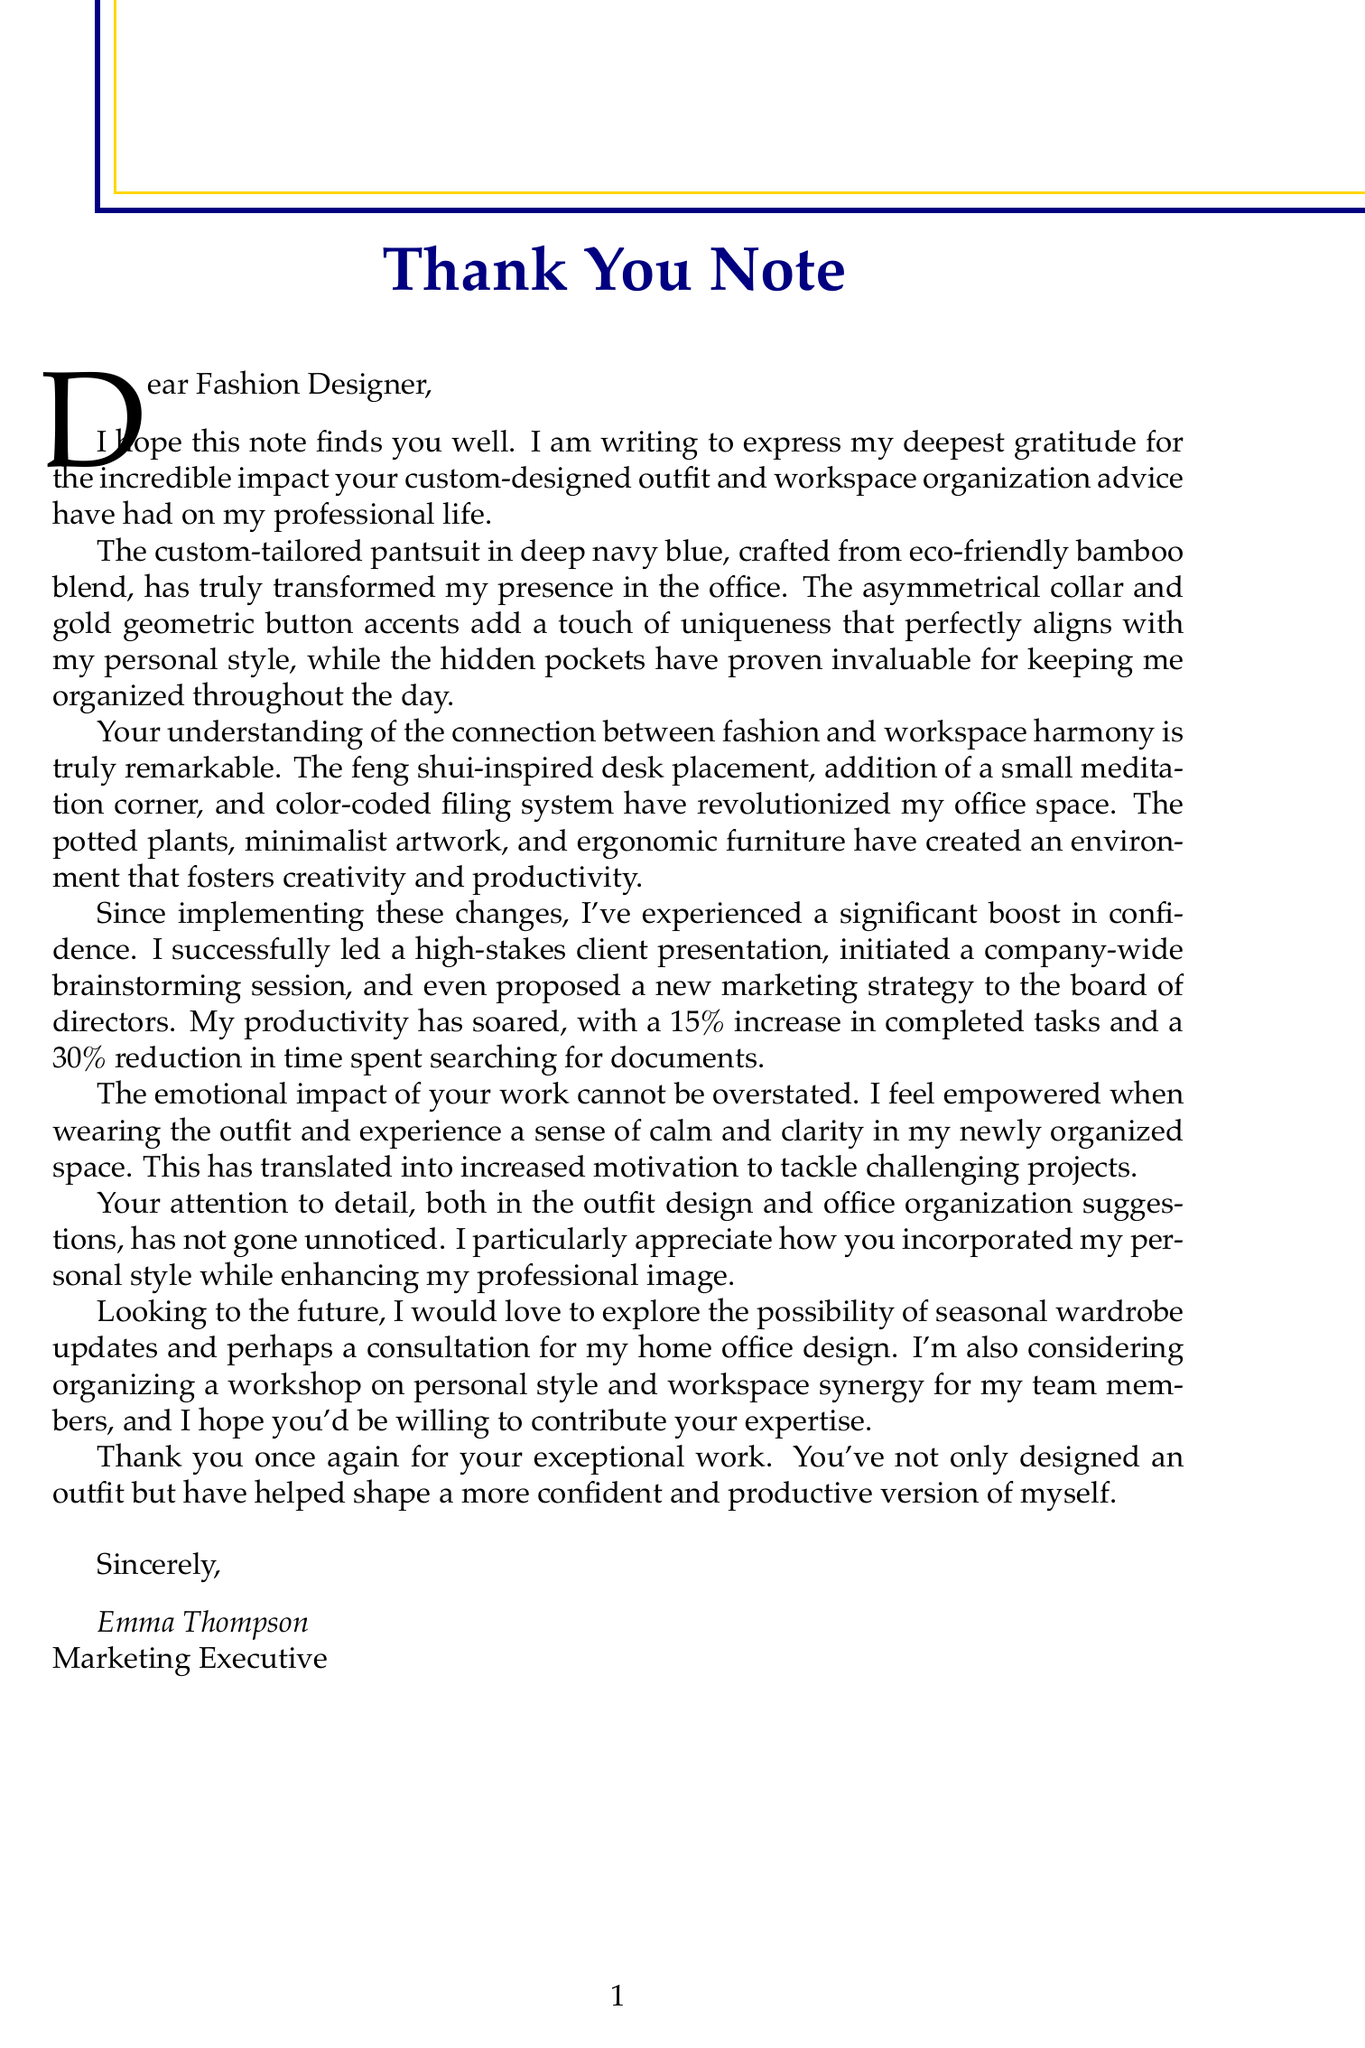What is the client's name? The client's name is mentioned at the beginning of the letter as Emma Thompson.
Answer: Emma Thompson What color is the custom-tailored pantsuit? The outfit description states the color of the pantsuit is deep navy blue.
Answer: Deep navy blue What percentage increase in completed tasks did the client experience? The productivity improvements section specifies a 15% increase in completed tasks.
Answer: 15% What type of furniture is mentioned in the office decor? The document refers to ergonomic furniture as part of the decor elements.
Answer: Ergonomic furniture Which feature of the outfit helps the client stay organized? The letter highlights hidden pockets as a feature that helps with organization.
Answer: Hidden pockets What emotional feeling does the client associate with wearing the outfit? The emotional impact section indicates the client feels empowered when wearing the outfit.
Answer: Empowered How much time did the client reduce searching for documents? The document notes a 30% reduction in time spent searching for documents.
Answer: 30% What future collaboration idea involves workshops? The client expresses interest in organizing a workshop on personal style and workspace synergy for team members.
Answer: Workshop on personal style and workspace synergy What design aspect did the client appreciate about the outfit? The client appreciated the incorporation of her personal style while enhancing professionalism.
Answer: Incorporating client's personal style while enhancing professionalism 